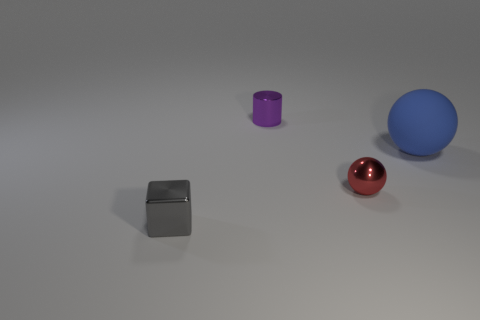What number of other cylinders are made of the same material as the small cylinder?
Provide a succinct answer. 0. How many other big matte objects have the same shape as the big blue rubber object?
Ensure brevity in your answer.  0. Is the number of gray cubes in front of the gray shiny thing the same as the number of cyan rubber objects?
Provide a short and direct response. Yes. There is a metal cube that is the same size as the shiny cylinder; what is its color?
Your answer should be very brief. Gray. Are there any other big blue rubber objects that have the same shape as the big blue matte object?
Your response must be concise. No. The object to the right of the metal object on the right side of the tiny shiny thing that is behind the small metallic ball is made of what material?
Provide a short and direct response. Rubber. What number of other objects are the same size as the purple thing?
Offer a very short reply. 2. The small metal cube has what color?
Give a very brief answer. Gray. What number of shiny things are blue objects or tiny yellow cylinders?
Offer a terse response. 0. Is there any other thing that has the same material as the blue ball?
Offer a very short reply. No. 